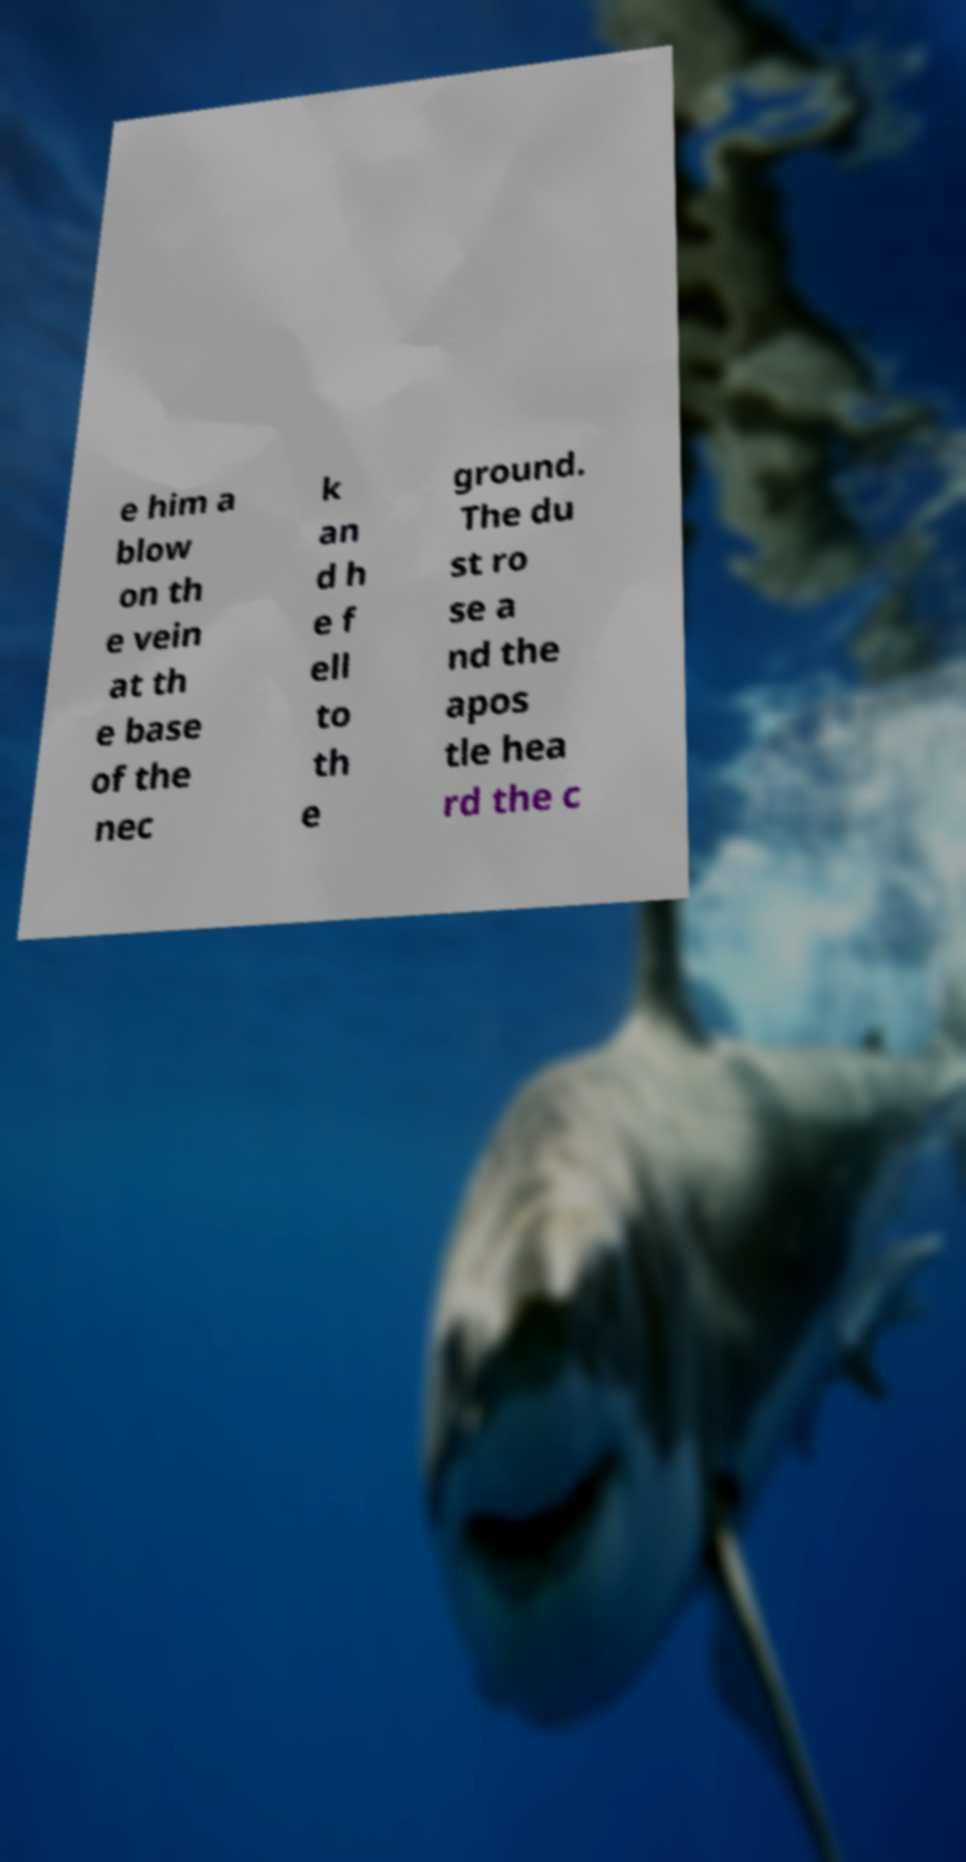Please identify and transcribe the text found in this image. e him a blow on th e vein at th e base of the nec k an d h e f ell to th e ground. The du st ro se a nd the apos tle hea rd the c 